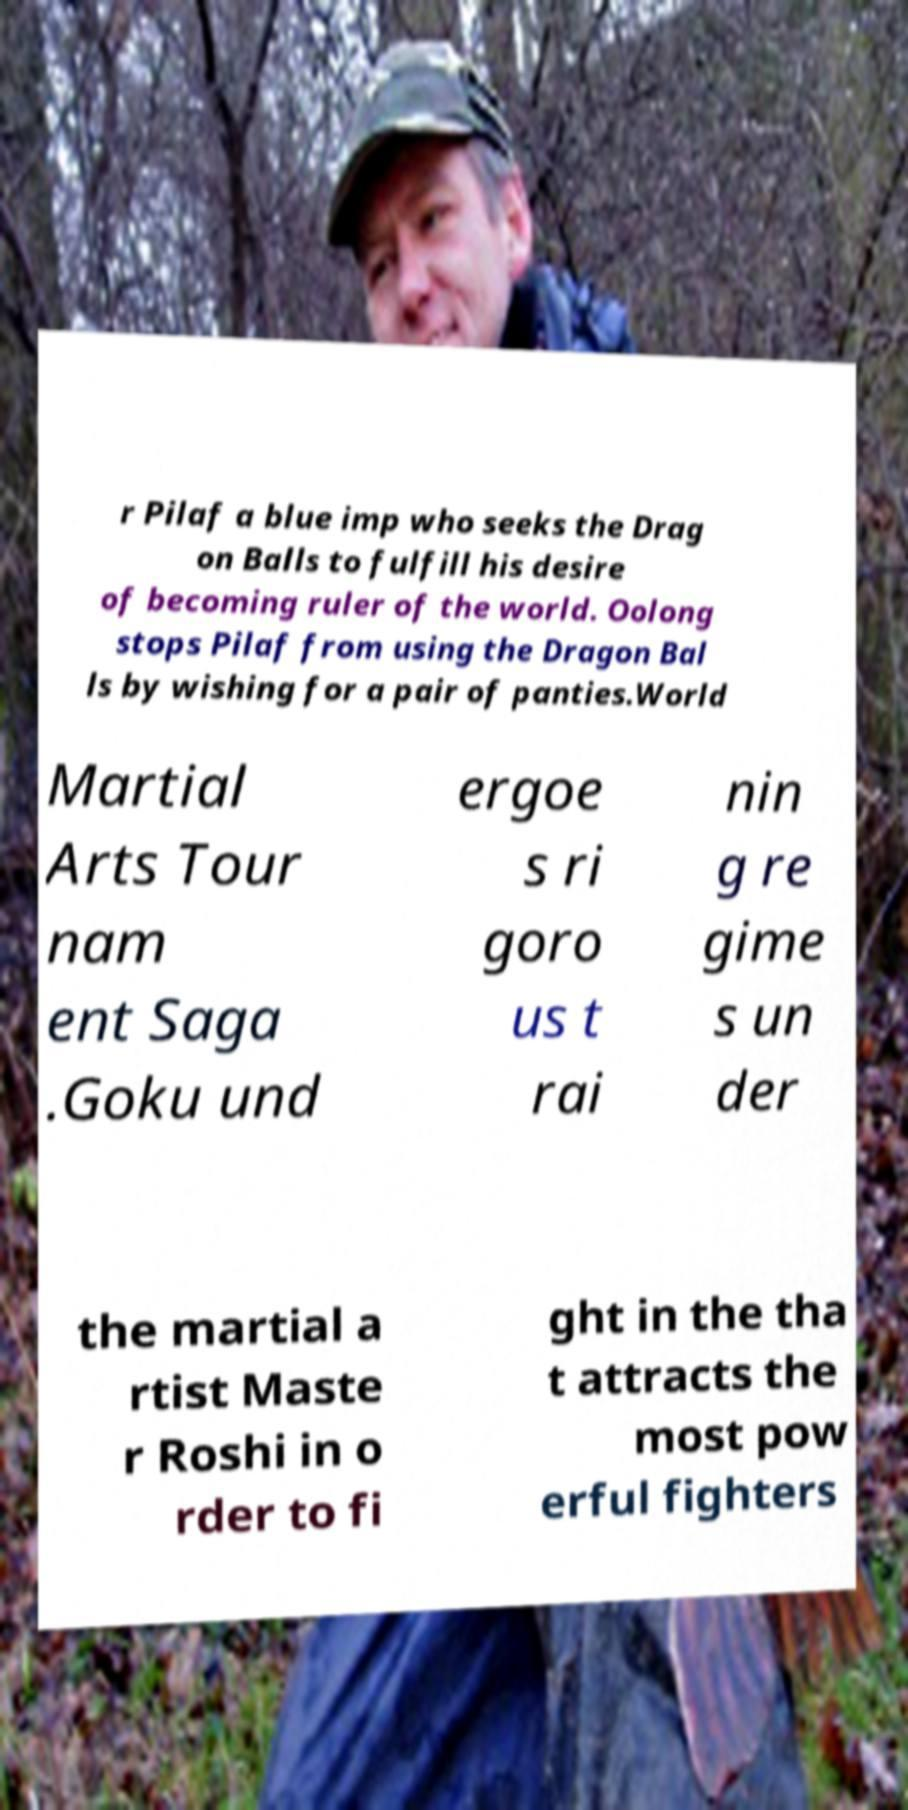Please read and relay the text visible in this image. What does it say? r Pilaf a blue imp who seeks the Drag on Balls to fulfill his desire of becoming ruler of the world. Oolong stops Pilaf from using the Dragon Bal ls by wishing for a pair of panties.World Martial Arts Tour nam ent Saga .Goku und ergoe s ri goro us t rai nin g re gime s un der the martial a rtist Maste r Roshi in o rder to fi ght in the tha t attracts the most pow erful fighters 